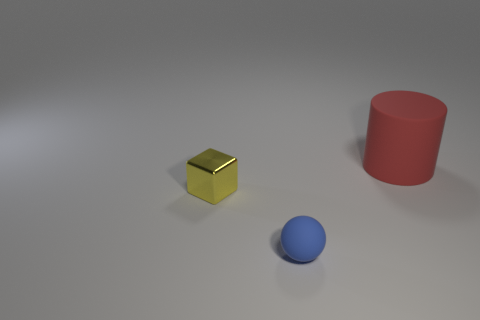Are there any other things that are made of the same material as the small cube? Without being able to inspect the objects physically or having more information, it's difficult to determine with certainty if they are made from the same material based solely on appearance. However, the objects depicted—a cube, a cylinder, and a sphere—have distinct shapes and colors which may suggest different materials. Typically, objects in such an image are used to demonstrate geometry or for visual composition in design. A more detailed analysis or description of the material properties would be required to accurately answer this question. 